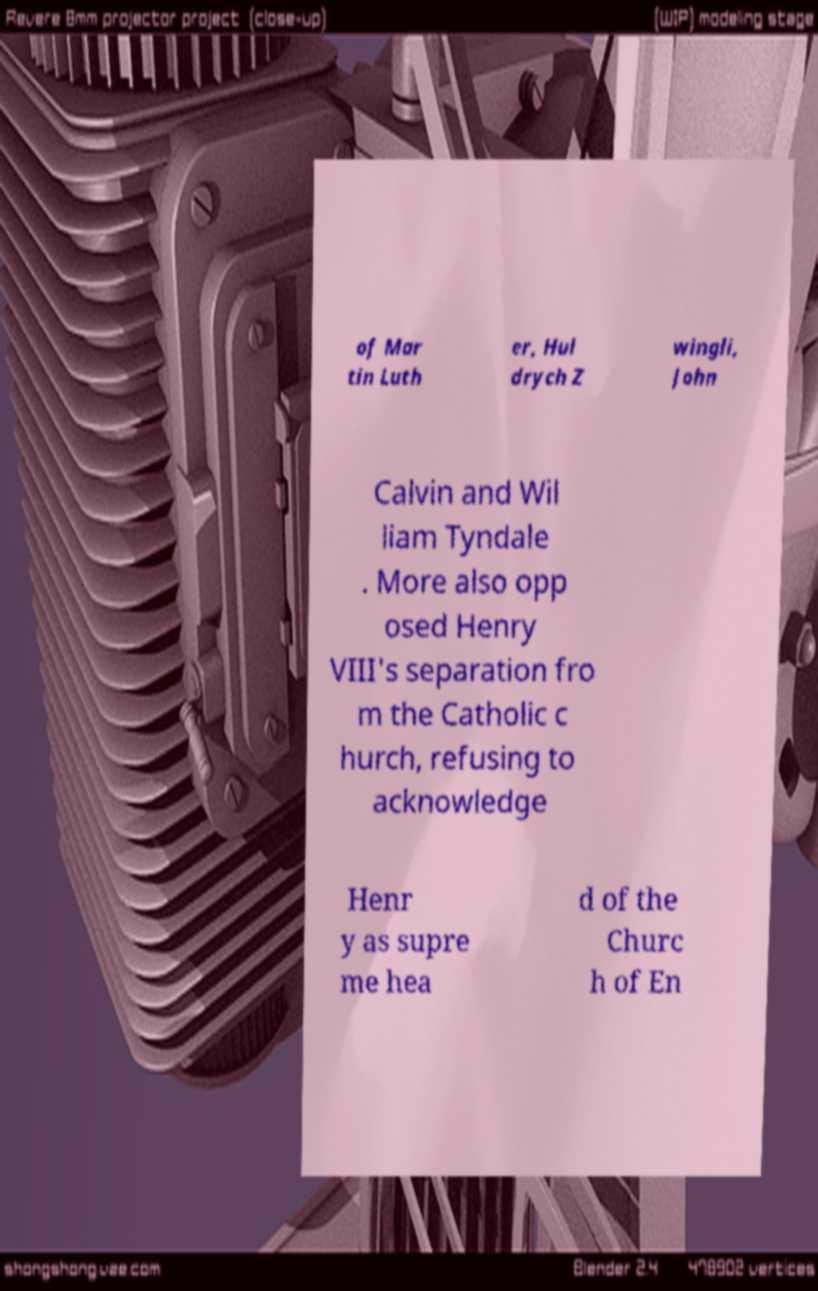Please read and relay the text visible in this image. What does it say? of Mar tin Luth er, Hul drych Z wingli, John Calvin and Wil liam Tyndale . More also opp osed Henry VIII's separation fro m the Catholic c hurch, refusing to acknowledge Henr y as supre me hea d of the Churc h of En 